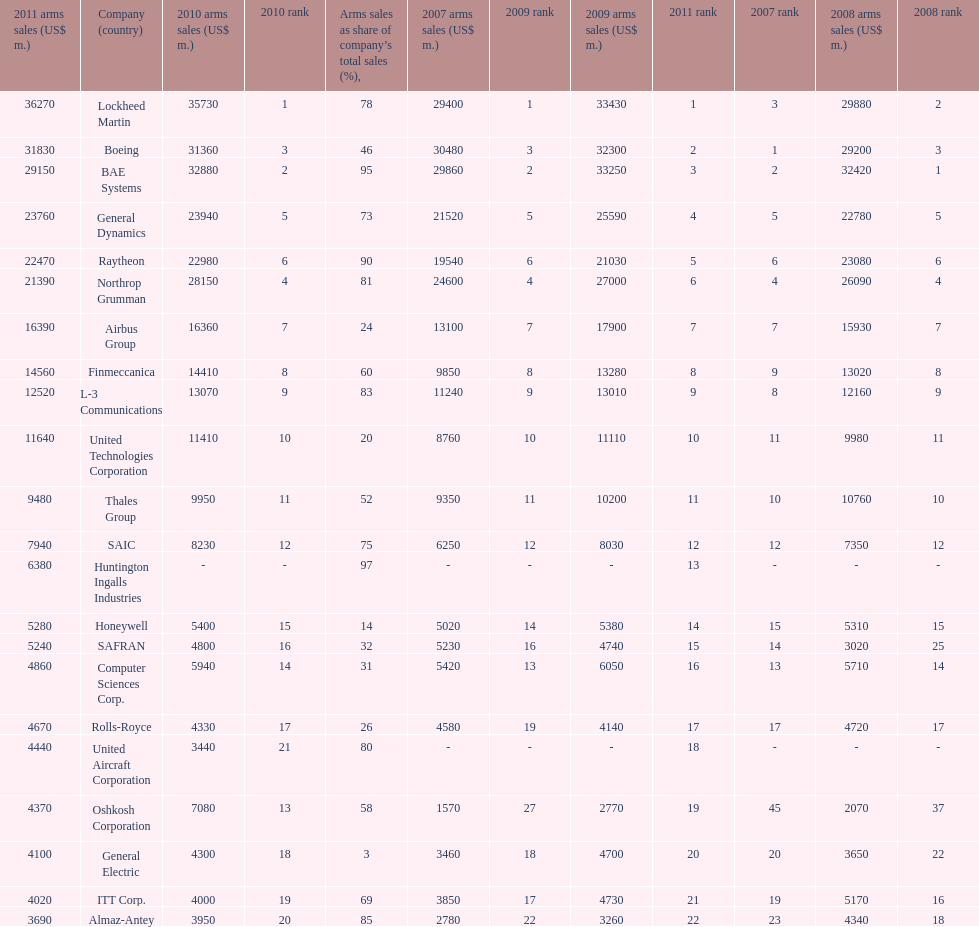Write the full table. {'header': ['2011 arms sales (US$ m.)', 'Company (country)', '2010 arms sales (US$ m.)', '2010 rank', 'Arms sales as share of company’s total sales (%),', '2007 arms sales (US$ m.)', '2009 rank', '2009 arms sales (US$ m.)', '2011 rank', '2007 rank', '2008 arms sales (US$ m.)', '2008 rank'], 'rows': [['36270', 'Lockheed Martin', '35730', '1', '78', '29400', '1', '33430', '1', '3', '29880', '2'], ['31830', 'Boeing', '31360', '3', '46', '30480', '3', '32300', '2', '1', '29200', '3'], ['29150', 'BAE Systems', '32880', '2', '95', '29860', '2', '33250', '3', '2', '32420', '1'], ['23760', 'General Dynamics', '23940', '5', '73', '21520', '5', '25590', '4', '5', '22780', '5'], ['22470', 'Raytheon', '22980', '6', '90', '19540', '6', '21030', '5', '6', '23080', '6'], ['21390', 'Northrop Grumman', '28150', '4', '81', '24600', '4', '27000', '6', '4', '26090', '4'], ['16390', 'Airbus Group', '16360', '7', '24', '13100', '7', '17900', '7', '7', '15930', '7'], ['14560', 'Finmeccanica', '14410', '8', '60', '9850', '8', '13280', '8', '9', '13020', '8'], ['12520', 'L-3 Communications', '13070', '9', '83', '11240', '9', '13010', '9', '8', '12160', '9'], ['11640', 'United Technologies Corporation', '11410', '10', '20', '8760', '10', '11110', '10', '11', '9980', '11'], ['9480', 'Thales Group', '9950', '11', '52', '9350', '11', '10200', '11', '10', '10760', '10'], ['7940', 'SAIC', '8230', '12', '75', '6250', '12', '8030', '12', '12', '7350', '12'], ['6380', 'Huntington Ingalls Industries', '-', '-', '97', '-', '-', '-', '13', '-', '-', '-'], ['5280', 'Honeywell', '5400', '15', '14', '5020', '14', '5380', '14', '15', '5310', '15'], ['5240', 'SAFRAN', '4800', '16', '32', '5230', '16', '4740', '15', '14', '3020', '25'], ['4860', 'Computer Sciences Corp.', '5940', '14', '31', '5420', '13', '6050', '16', '13', '5710', '14'], ['4670', 'Rolls-Royce', '4330', '17', '26', '4580', '19', '4140', '17', '17', '4720', '17'], ['4440', 'United Aircraft Corporation', '3440', '21', '80', '-', '-', '-', '18', '-', '-', '-'], ['4370', 'Oshkosh Corporation', '7080', '13', '58', '1570', '27', '2770', '19', '45', '2070', '37'], ['4100', 'General Electric', '4300', '18', '3', '3460', '18', '4700', '20', '20', '3650', '22'], ['4020', 'ITT Corp.', '4000', '19', '69', '3850', '17', '4730', '21', '19', '5170', '16'], ['3690', 'Almaz-Antey', '3950', '20', '85', '2780', '22', '3260', '22', '23', '4340', '18']]} Which company had the highest 2009 arms sales? Lockheed Martin. 